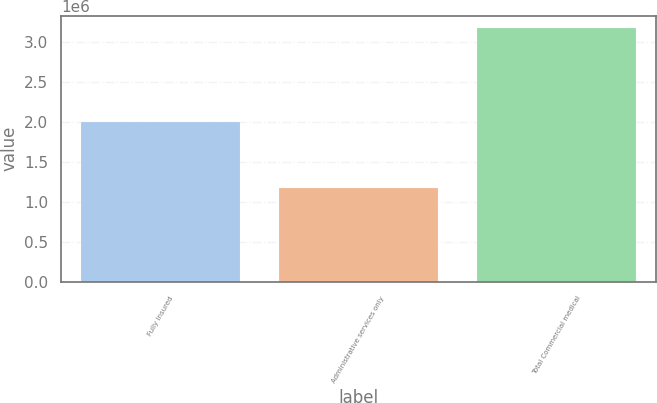Convert chart to OTSL. <chart><loc_0><loc_0><loc_500><loc_500><bar_chart><fcel>Fully insured<fcel>Administrative services only<fcel>Total Commercial medical<nl><fcel>1.9998e+06<fcel>1.171e+06<fcel>3.1708e+06<nl></chart> 